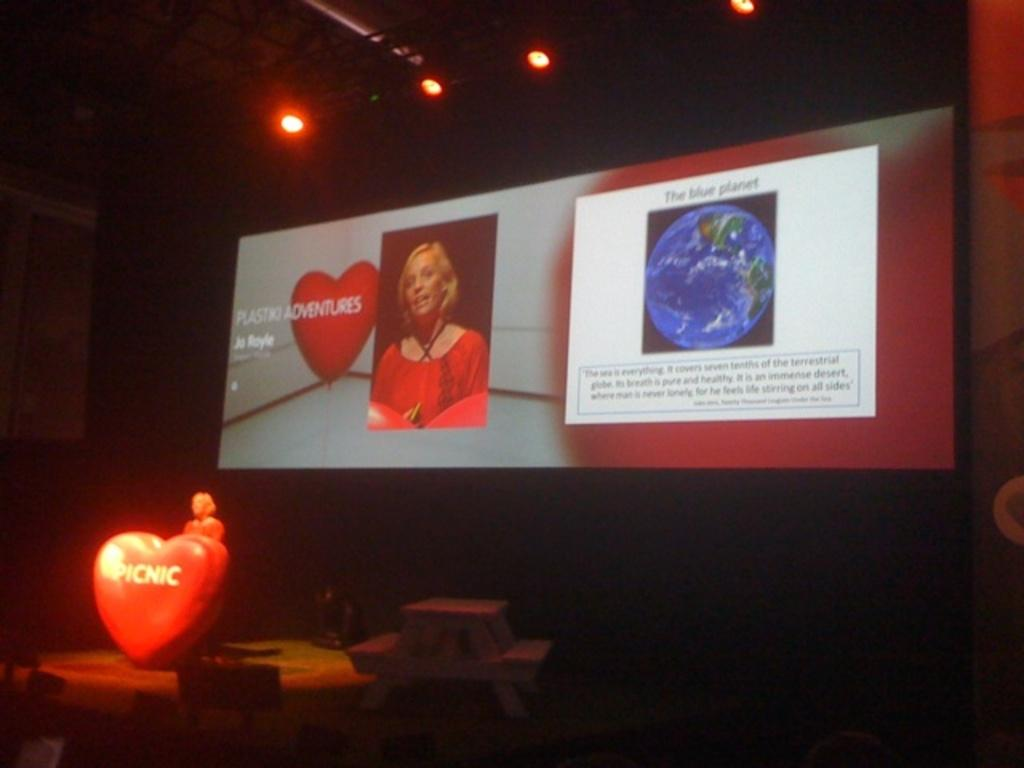What is the main object in the center of the image? There is a screen in the center of the image. What can be seen at the top of the image? There are lights at the top of the image. What is located on the left side of the image? There is a bench and a podium on the left side of the image. Can you describe the people in the image? There are women in the image. What other objects are present in the image? There are other objects in the image. How does the stream flow through the image? There is no stream present in the image. What type of spot is visible on the screen in the image? There is no spot visible on the screen in the image. 